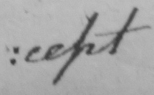Please provide the text content of this handwritten line. : cept 